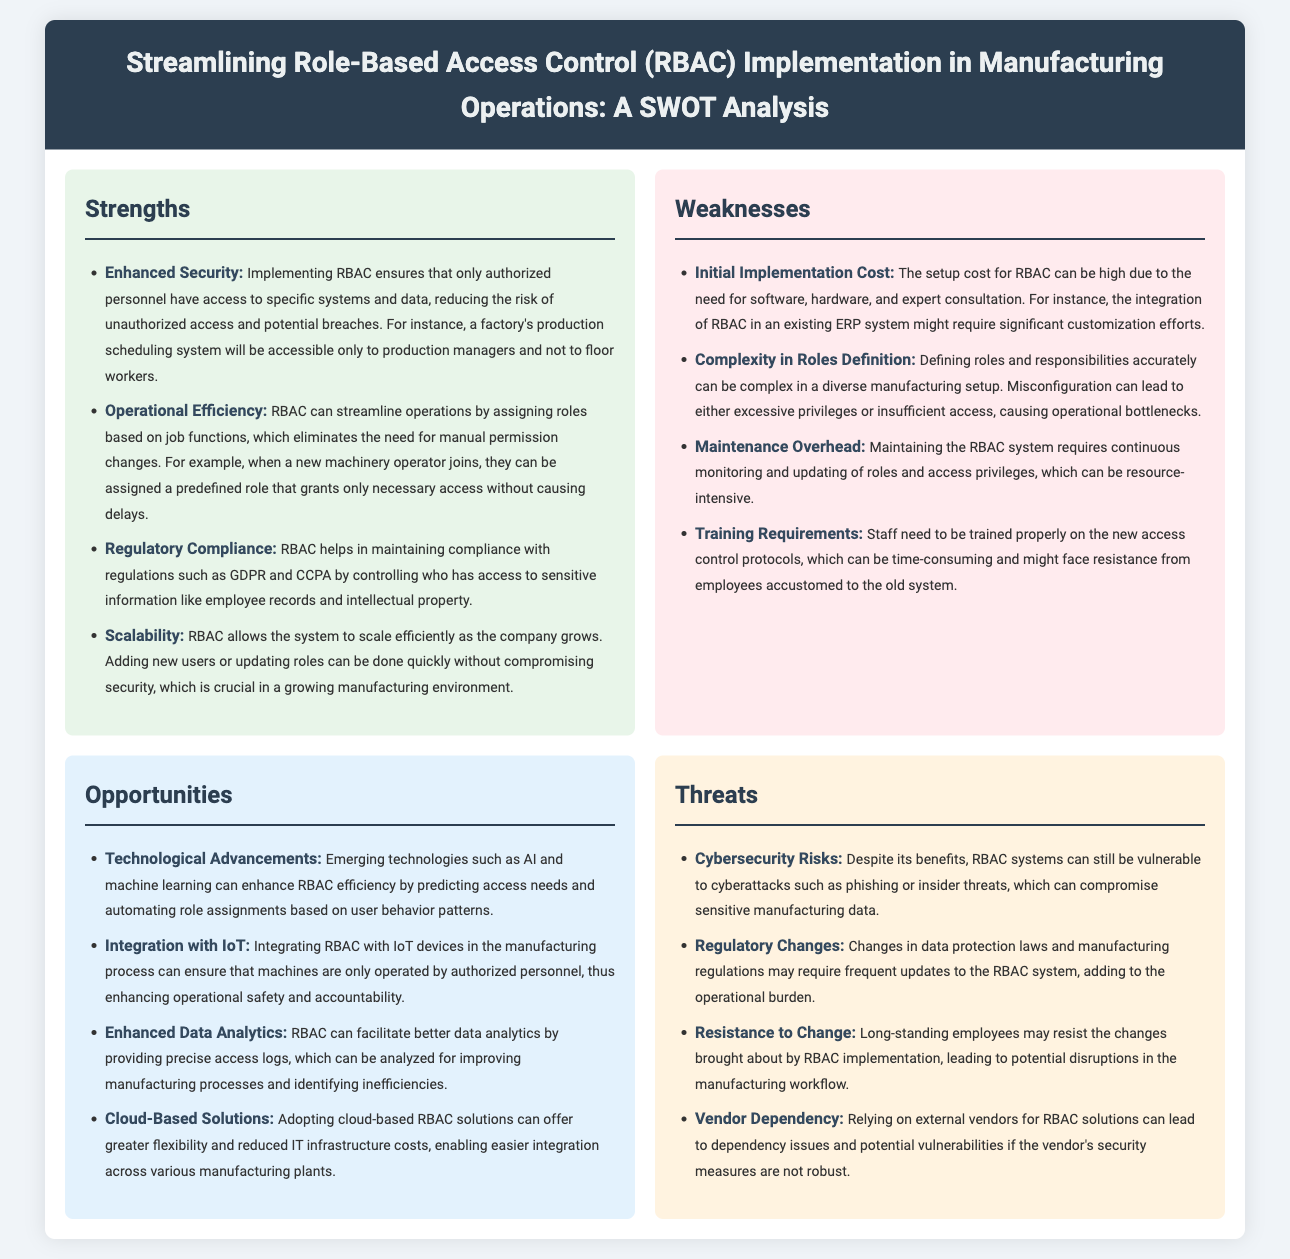what is a key benefit of implementing RBAC? Enhanced Security is a primary benefit mentioned in the document, ensuring only authorized personnel have access.
Answer: Enhanced Security what is one weakness related to the initial stages of RBAC implementation? The document states that the Initial Implementation Cost can be high due to various expenses like software and expert consultation.
Answer: Initial Implementation Cost which opportunity relates to the use of emerging technologies? The document highlights that Technological Advancements can enhance RBAC efficiency through AI and machine learning.
Answer: Technological Advancements what threat involves compliance with laws? Regulatory Changes are identified as a threat that may require frequent updates to the RBAC system.
Answer: Regulatory Changes how does RBAC impact operational efficiency? The document mentions that RBAC can streamline operations by assigning roles based on job functions, which eliminates manual permission changes.
Answer: Operational Efficiency what is one of the training requirements mentioned? Staff need to be trained properly on the new access control protocols as noted in the weaknesses section.
Answer: Training Requirements 